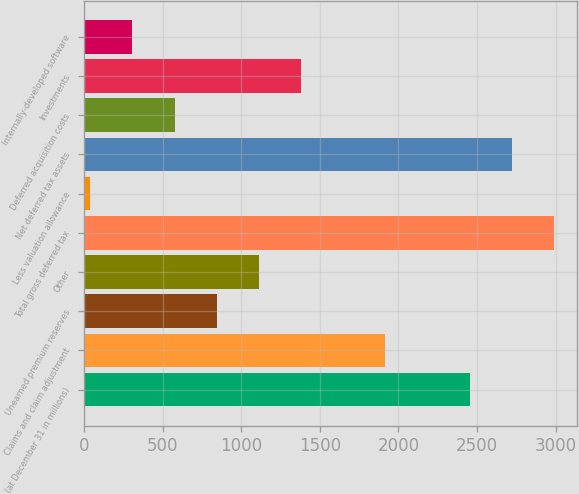Convert chart. <chart><loc_0><loc_0><loc_500><loc_500><bar_chart><fcel>(at December 31 in millions)<fcel>Claims and claim adjustment<fcel>Unearned premium reserves<fcel>Other<fcel>Total gross deferred tax<fcel>Less valuation allowance<fcel>Net deferred tax assets<fcel>Deferred acquisition costs<fcel>Investments<fcel>Internally-developed software<nl><fcel>2451.9<fcel>1916.5<fcel>845.7<fcel>1113.4<fcel>2987.3<fcel>36<fcel>2719.6<fcel>578<fcel>1381.1<fcel>303.7<nl></chart> 